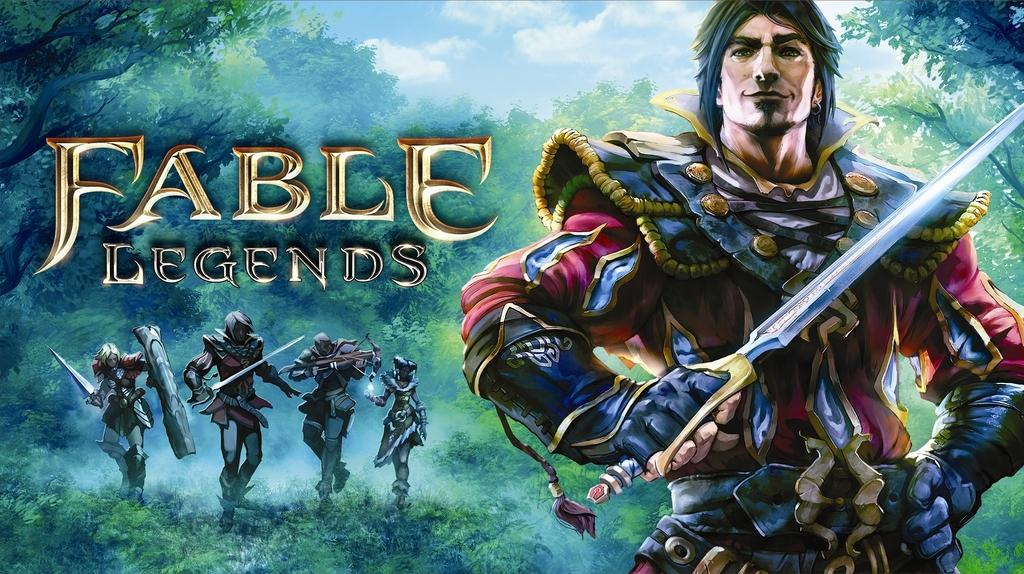<image>
Share a concise interpretation of the image provided. An artistic drawing of the video game Fable Legends. 